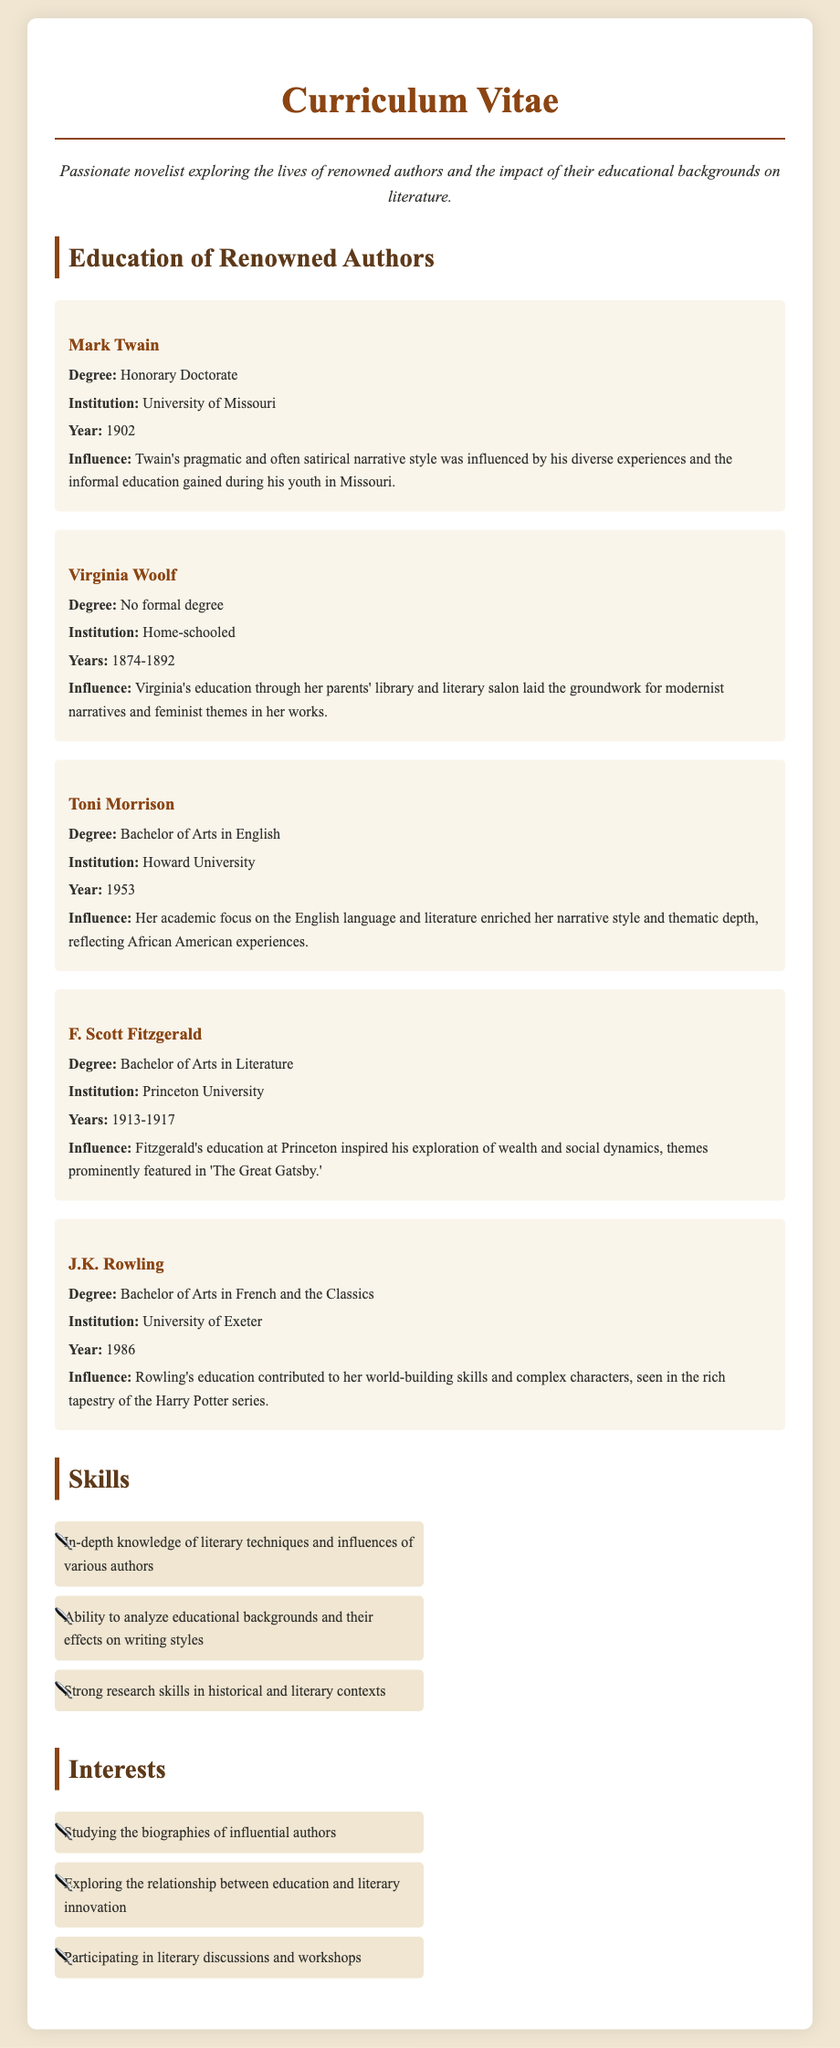What degree did Mark Twain receive? The document states that Mark Twain received an Honorary Doctorate from the University of Missouri.
Answer: Honorary Doctorate Which university did Toni Morrison attend? According to the document, Toni Morrison attended Howard University to earn her degree.
Answer: Howard University What year did Virginia Woolf finish her home-schooling? The document lists the years of Virginia Woolf's home-schooling from 1874 to 1892, indicating that she finished in 1892.
Answer: 1892 How did J.K. Rowling's education influence her writing? The document explains that her education contributed to her world-building skills and complex characters in the Harry Potter series.
Answer: World-building skills What theme is prominently featured in F. Scott Fitzgerald's 'The Great Gatsby'? The document mentions that Fitzgerald explored wealth and social dynamics in 'The Great Gatsby.'
Answer: Wealth and social dynamics What type of educational background did Virginia Woolf have? The document states that Virginia Woolf had no formal degree and was home-schooled instead.
Answer: No formal degree What is a skill highlighted in the document related to literary authors? The document highlights the skill of analyzing educational backgrounds and their effects on writing styles as a key point.
Answer: Analyzing educational backgrounds How did Twain's experiences influence his writing style? The document indicates that Twain's pragmatic and often satirical narrative style was influenced by diverse experiences he gained during his youth.
Answer: Diverse experiences What is a common interest mentioned in the document related to literature? The document lists studying the biographies of influential authors as a common interest.
Answer: Studying biographies of influential authors 